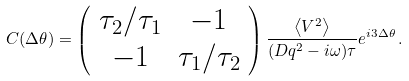Convert formula to latex. <formula><loc_0><loc_0><loc_500><loc_500>C ( \Delta \theta ) = \left ( \begin{array} { c c } \tau _ { 2 } / \tau _ { 1 } & - 1 \\ - 1 & \tau _ { 1 } / \tau _ { 2 } \end{array} \right ) \frac { \left \langle V ^ { 2 } \right \rangle } { ( D q ^ { 2 } - i \omega ) \tau } e ^ { i 3 \Delta \theta } \, .</formula> 